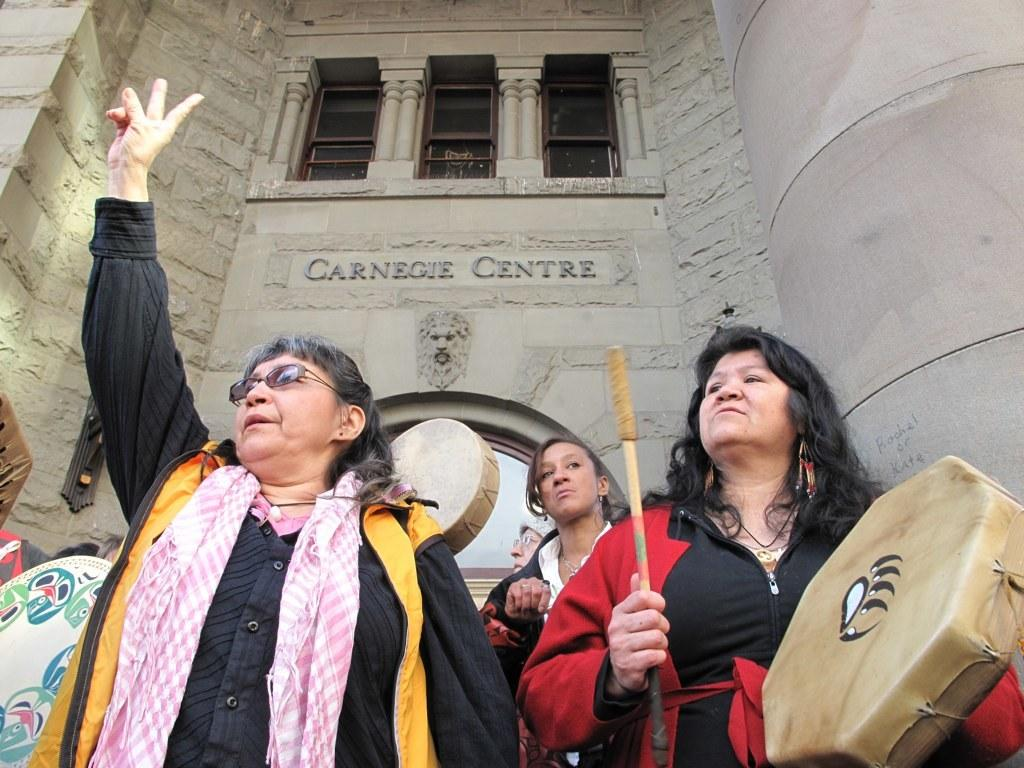What type of structure is visible in the image? There is a building with a window in the image. What are the people in the image doing? They are holding a musical drum with sticks. Can you describe the clothing of one of the women in the image? There is a woman wearing a scarf and a yellow jacket in the image. How many women are wearing jackets in the image? There are two women wearing jackets in the image, one in a red jacket and another in a yellow jacket. What direction are the police officers facing in the image? There are no police officers present in the image. Can you describe the wing of the bird in the image? There is no bird or wing present in the image. 